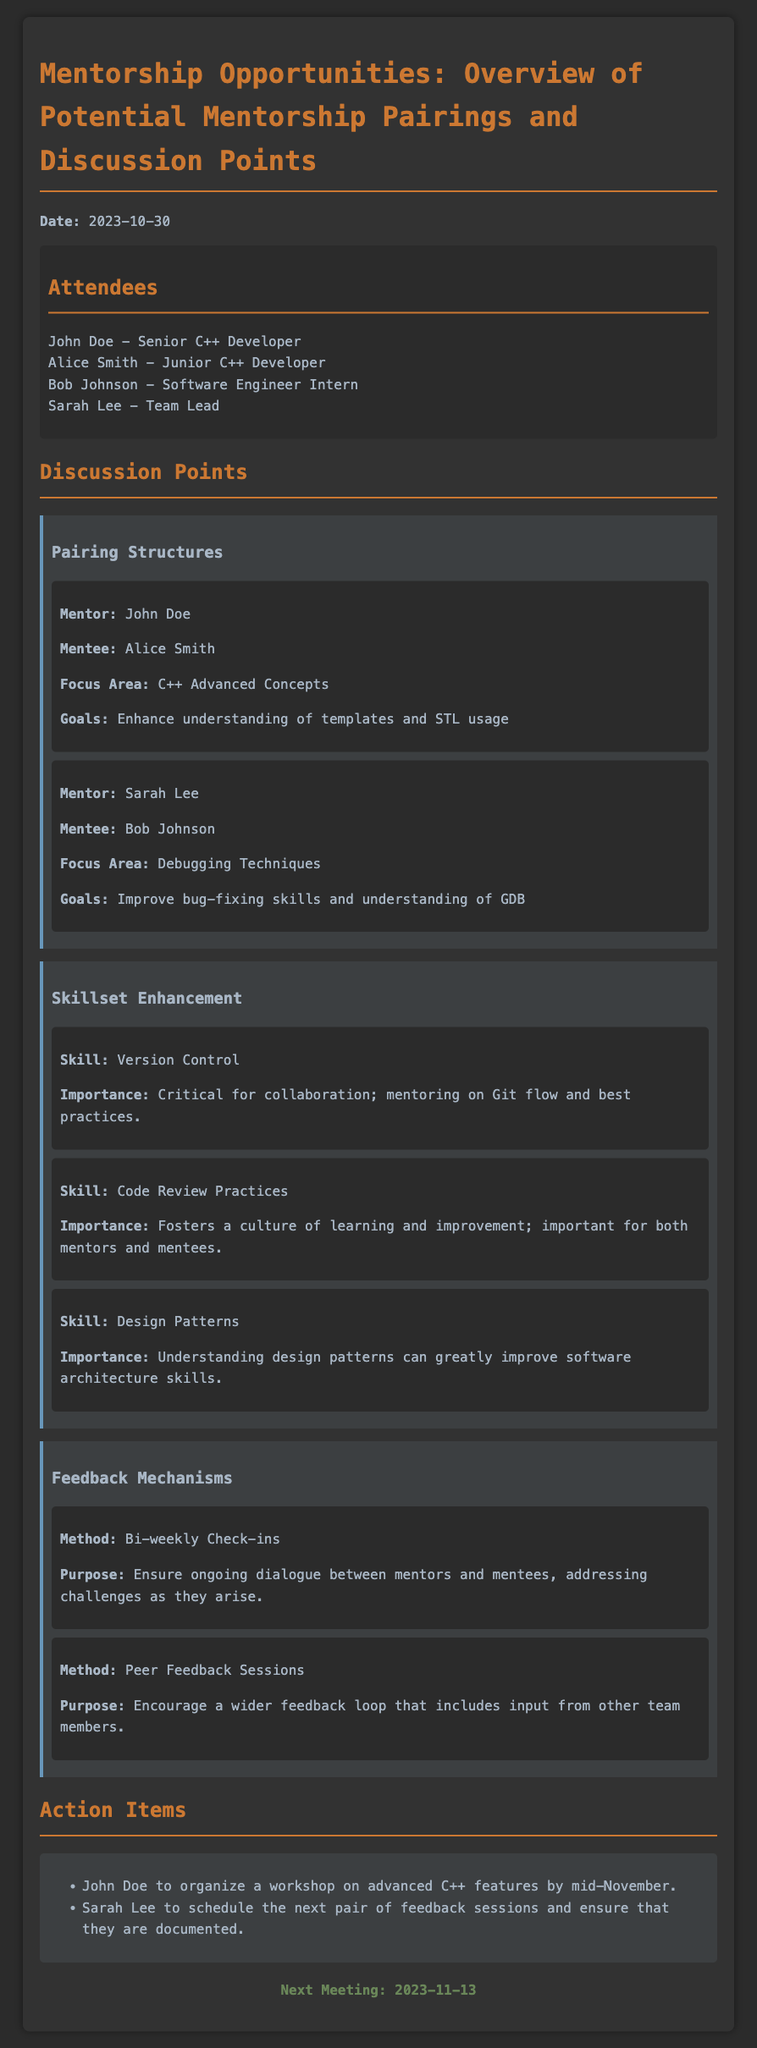What is the date of the meeting? The meeting date is specified at the top, clearly labeled.
Answer: 2023-10-30 Who is the mentor for Alice Smith? The document lists mentor-mentee pairings that include names and roles.
Answer: John Doe What is the focus area for Bob Johnson's mentorship? Mentorship pairings include focus areas for development, particularly for each mentee.
Answer: Debugging Techniques What skill is highlighted as critical for collaboration? The document discusses various skills and their importance in team settings.
Answer: Version Control What are the two feedback methods mentioned? The document provides information on feedback mechanisms used in the mentoring process.
Answer: Bi-weekly Check-ins, Peer Feedback Sessions When is the next meeting scheduled? The document ends with a section that mentions the date for the subsequent meeting.
Answer: 2023-11-13 What is one of the goals for John Doe's mentorship with Alice Smith? Goals are specified for each pairing, detailing desired educational outcomes.
Answer: Enhance understanding of templates and STL usage Who is responsible for organizing the advanced C++ workshop? Action items in the document specify responsibilities for tasks based on the discussion.
Answer: John Doe What is the importance of Code Review Practices? The document details the significance of skills discussed during the meeting.
Answer: Fosters a culture of learning and improvement 